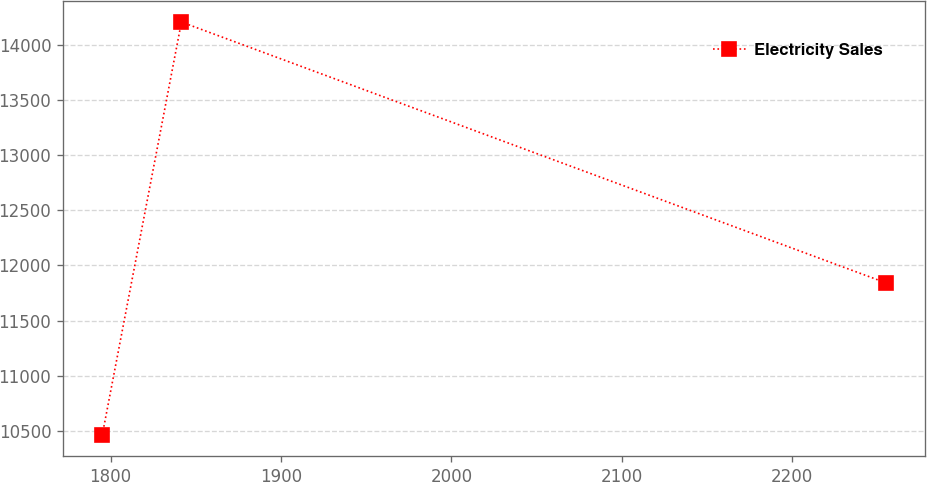<chart> <loc_0><loc_0><loc_500><loc_500><line_chart><ecel><fcel>Electricity Sales<nl><fcel>1795.05<fcel>10457.9<nl><fcel>1841.56<fcel>14208.6<nl><fcel>2254.98<fcel>11842.6<nl></chart> 